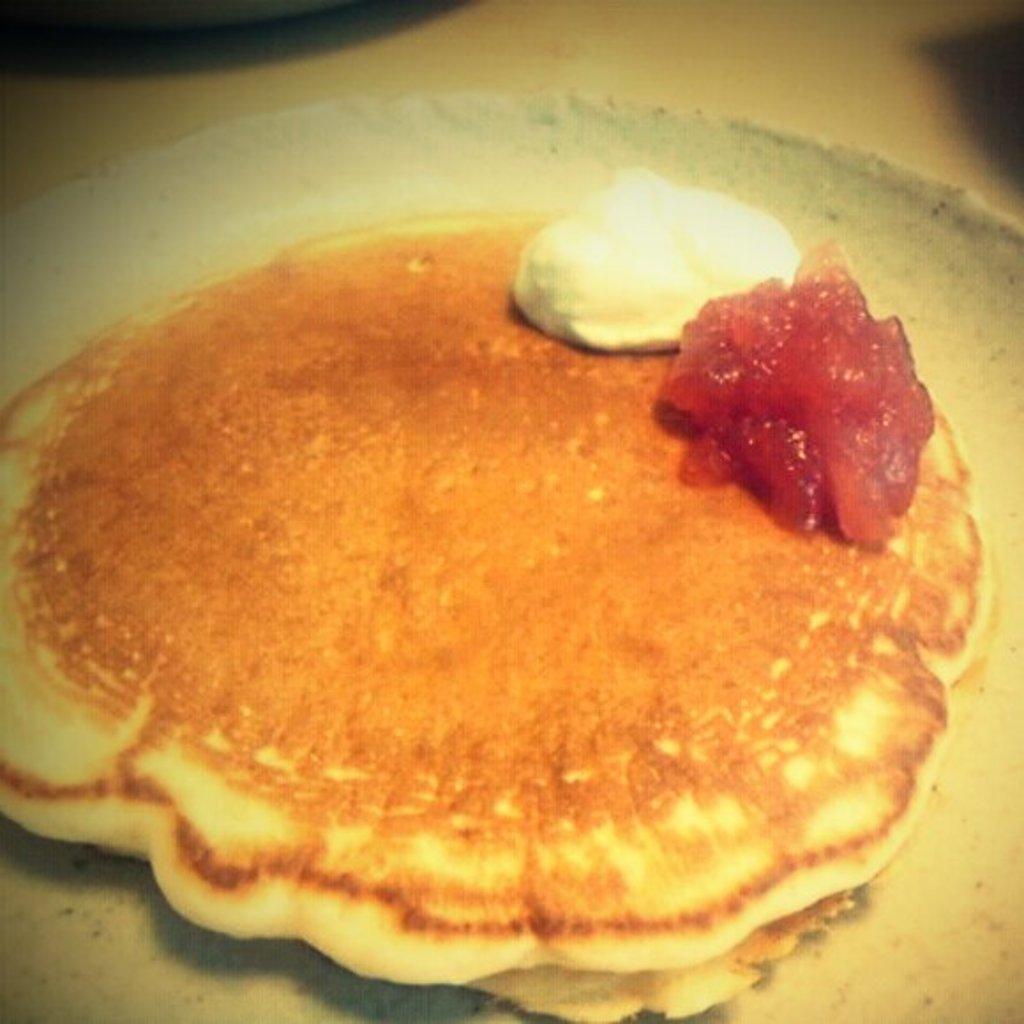Can you describe this image briefly? In the picture we can see a plate with a food item. 